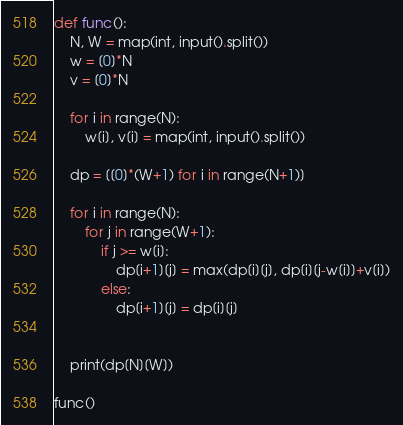<code> <loc_0><loc_0><loc_500><loc_500><_Python_>def func():
    N, W = map(int, input().split())
    w = [0]*N
    v = [0]*N

    for i in range(N):
        w[i], v[i] = map(int, input().split())

    dp = [[0]*(W+1) for i in range(N+1)]

    for i in range(N):
        for j in range(W+1):
            if j >= w[i]:
                dp[i+1][j] = max(dp[i][j], dp[i][j-w[i]]+v[i])
            else:
                dp[i+1][j] = dp[i][j]


    print(dp[N][W])

func()</code> 